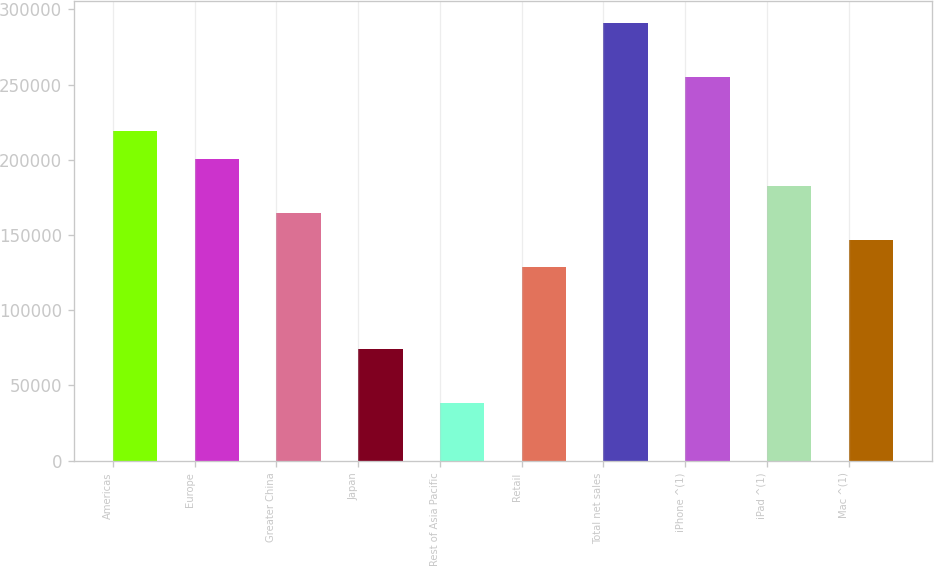Convert chart to OTSL. <chart><loc_0><loc_0><loc_500><loc_500><bar_chart><fcel>Americas<fcel>Europe<fcel>Greater China<fcel>Japan<fcel>Rest of Asia Pacific<fcel>Retail<fcel>Total net sales<fcel>iPhone ^(1)<fcel>iPad ^(1)<fcel>Mac ^(1)<nl><fcel>218897<fcel>200846<fcel>164744<fcel>74489.6<fcel>38387.8<fcel>128642<fcel>291100<fcel>254999<fcel>182795<fcel>146693<nl></chart> 